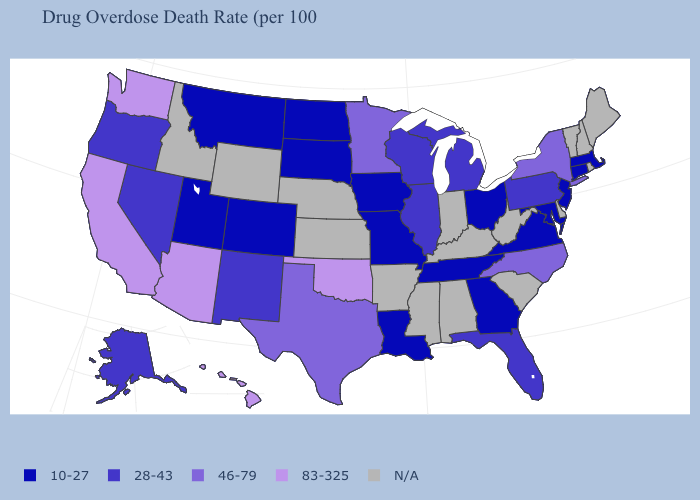What is the value of Vermont?
Short answer required. N/A. Does Texas have the lowest value in the USA?
Keep it brief. No. What is the value of New Mexico?
Write a very short answer. 28-43. Name the states that have a value in the range 28-43?
Quick response, please. Alaska, Florida, Illinois, Michigan, Nevada, New Mexico, Oregon, Pennsylvania, Wisconsin. Name the states that have a value in the range 83-325?
Give a very brief answer. Arizona, California, Hawaii, Oklahoma, Washington. Among the states that border California , does Nevada have the highest value?
Concise answer only. No. Name the states that have a value in the range 28-43?
Be succinct. Alaska, Florida, Illinois, Michigan, Nevada, New Mexico, Oregon, Pennsylvania, Wisconsin. What is the value of Texas?
Short answer required. 46-79. What is the value of Oregon?
Short answer required. 28-43. Does Hawaii have the highest value in the West?
Concise answer only. Yes. Does Florida have the highest value in the USA?
Quick response, please. No. Does the first symbol in the legend represent the smallest category?
Concise answer only. Yes. Name the states that have a value in the range N/A?
Quick response, please. Alabama, Arkansas, Delaware, Idaho, Indiana, Kansas, Kentucky, Maine, Mississippi, Nebraska, New Hampshire, Rhode Island, South Carolina, Vermont, West Virginia, Wyoming. 